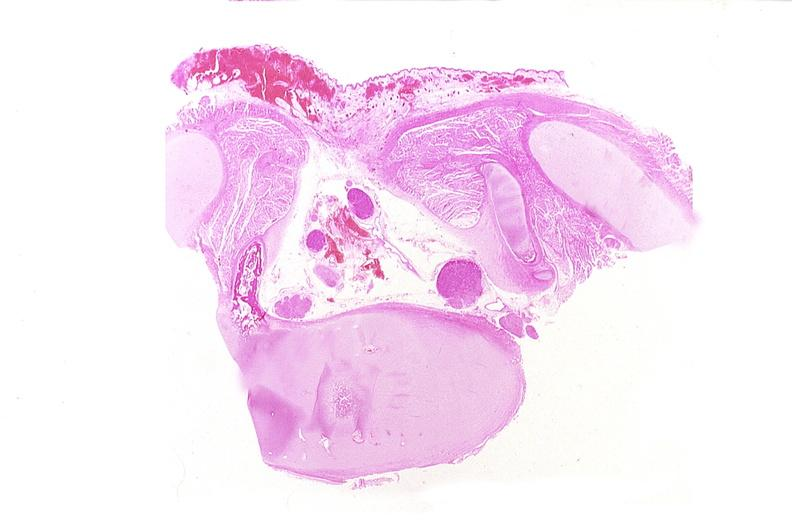where is this?
Answer the question using a single word or phrase. Nervous 